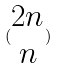<formula> <loc_0><loc_0><loc_500><loc_500>( \begin{matrix} 2 n \\ n \end{matrix} )</formula> 